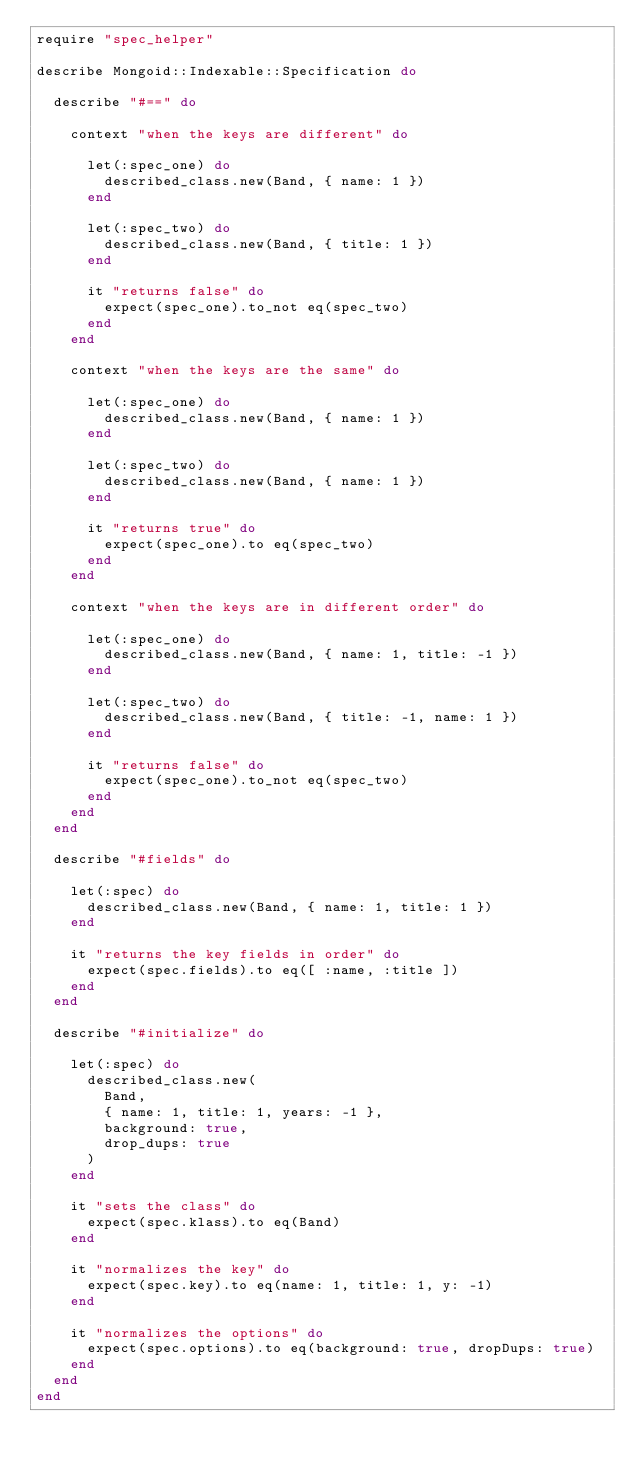Convert code to text. <code><loc_0><loc_0><loc_500><loc_500><_Ruby_>require "spec_helper"

describe Mongoid::Indexable::Specification do

  describe "#==" do

    context "when the keys are different" do

      let(:spec_one) do
        described_class.new(Band, { name: 1 })
      end

      let(:spec_two) do
        described_class.new(Band, { title: 1 })
      end

      it "returns false" do
        expect(spec_one).to_not eq(spec_two)
      end
    end

    context "when the keys are the same" do

      let(:spec_one) do
        described_class.new(Band, { name: 1 })
      end

      let(:spec_two) do
        described_class.new(Band, { name: 1 })
      end

      it "returns true" do
        expect(spec_one).to eq(spec_two)
      end
    end

    context "when the keys are in different order" do

      let(:spec_one) do
        described_class.new(Band, { name: 1, title: -1 })
      end

      let(:spec_two) do
        described_class.new(Band, { title: -1, name: 1 })
      end

      it "returns false" do
        expect(spec_one).to_not eq(spec_two)
      end
    end
  end

  describe "#fields" do

    let(:spec) do
      described_class.new(Band, { name: 1, title: 1 })
    end

    it "returns the key fields in order" do
      expect(spec.fields).to eq([ :name, :title ])
    end
  end

  describe "#initialize" do

    let(:spec) do
      described_class.new(
        Band,
        { name: 1, title: 1, years: -1 },
        background: true,
        drop_dups: true
      )
    end

    it "sets the class" do
      expect(spec.klass).to eq(Band)
    end

    it "normalizes the key" do
      expect(spec.key).to eq(name: 1, title: 1, y: -1)
    end

    it "normalizes the options" do
      expect(spec.options).to eq(background: true, dropDups: true)
    end
  end
end
</code> 